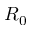<formula> <loc_0><loc_0><loc_500><loc_500>R _ { 0 }</formula> 